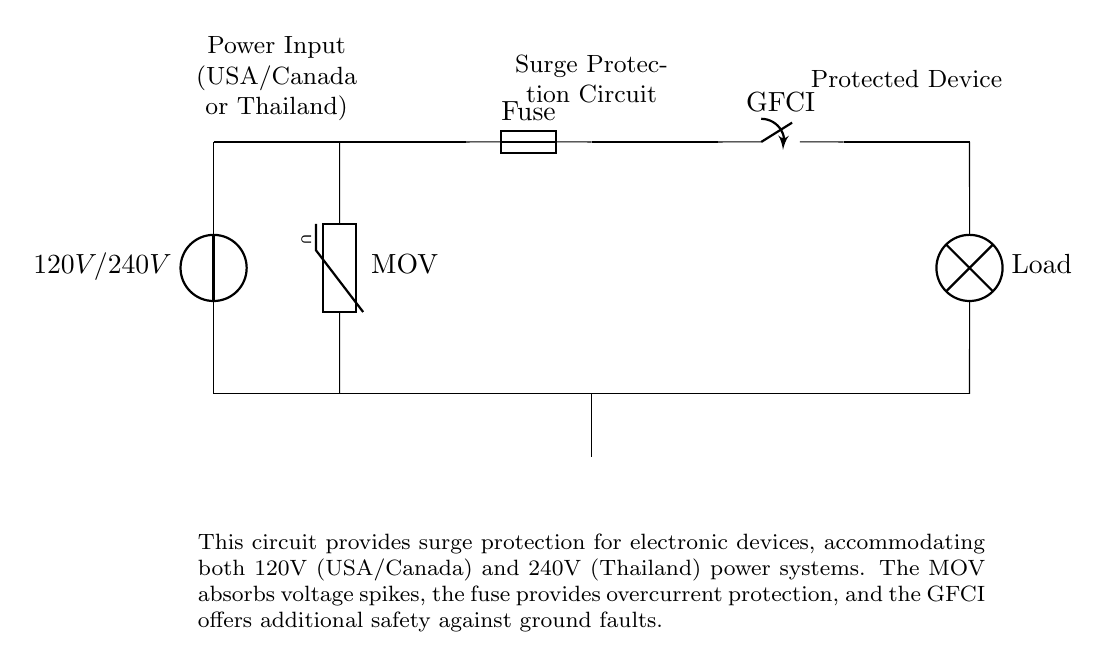What type of voltage source is used in this circuit? The circuit uses a voltage source labeled as 120V/240V, which indicates it can accommodate power systems from both North America and Thailand.
Answer: 120V/240V What is the purpose of the MOV in this circuit? The MOV, or Metal Oxide Varistor, is placed in the circuit to absorb voltage spikes, which helps to protect sensitive electronic devices from sudden surges in voltage.
Answer: Surge protection How many primary protective devices are present in this circuit? There are three primary protective devices: the MOV, the fuse, and the GFCI. Each plays a crucial role in safeguarding the connected electronics by addressing different types of electrical issues.
Answer: Three Which component provides overcurrent protection? The fuse is specifically designed to break the circuit when the current exceeds a safe level, thus protecting appliances from potential damage due to overcurrent conditions.
Answer: Fuse What is the role of the GFCI in this circuit? The Ground Fault Circuit Interrupter (GFCI) is included to detect and interrupt ground faults, providing an important layer of safety, particularly in damp or wet environments.
Answer: Ground fault protection How does this circuit accommodate different countries' power systems? The circuit is designed to handle both 120V and 240V input voltages, making it versatile and suitable for use in different countries, including the USA, Canada, and Thailand.
Answer: Voltage versatility 